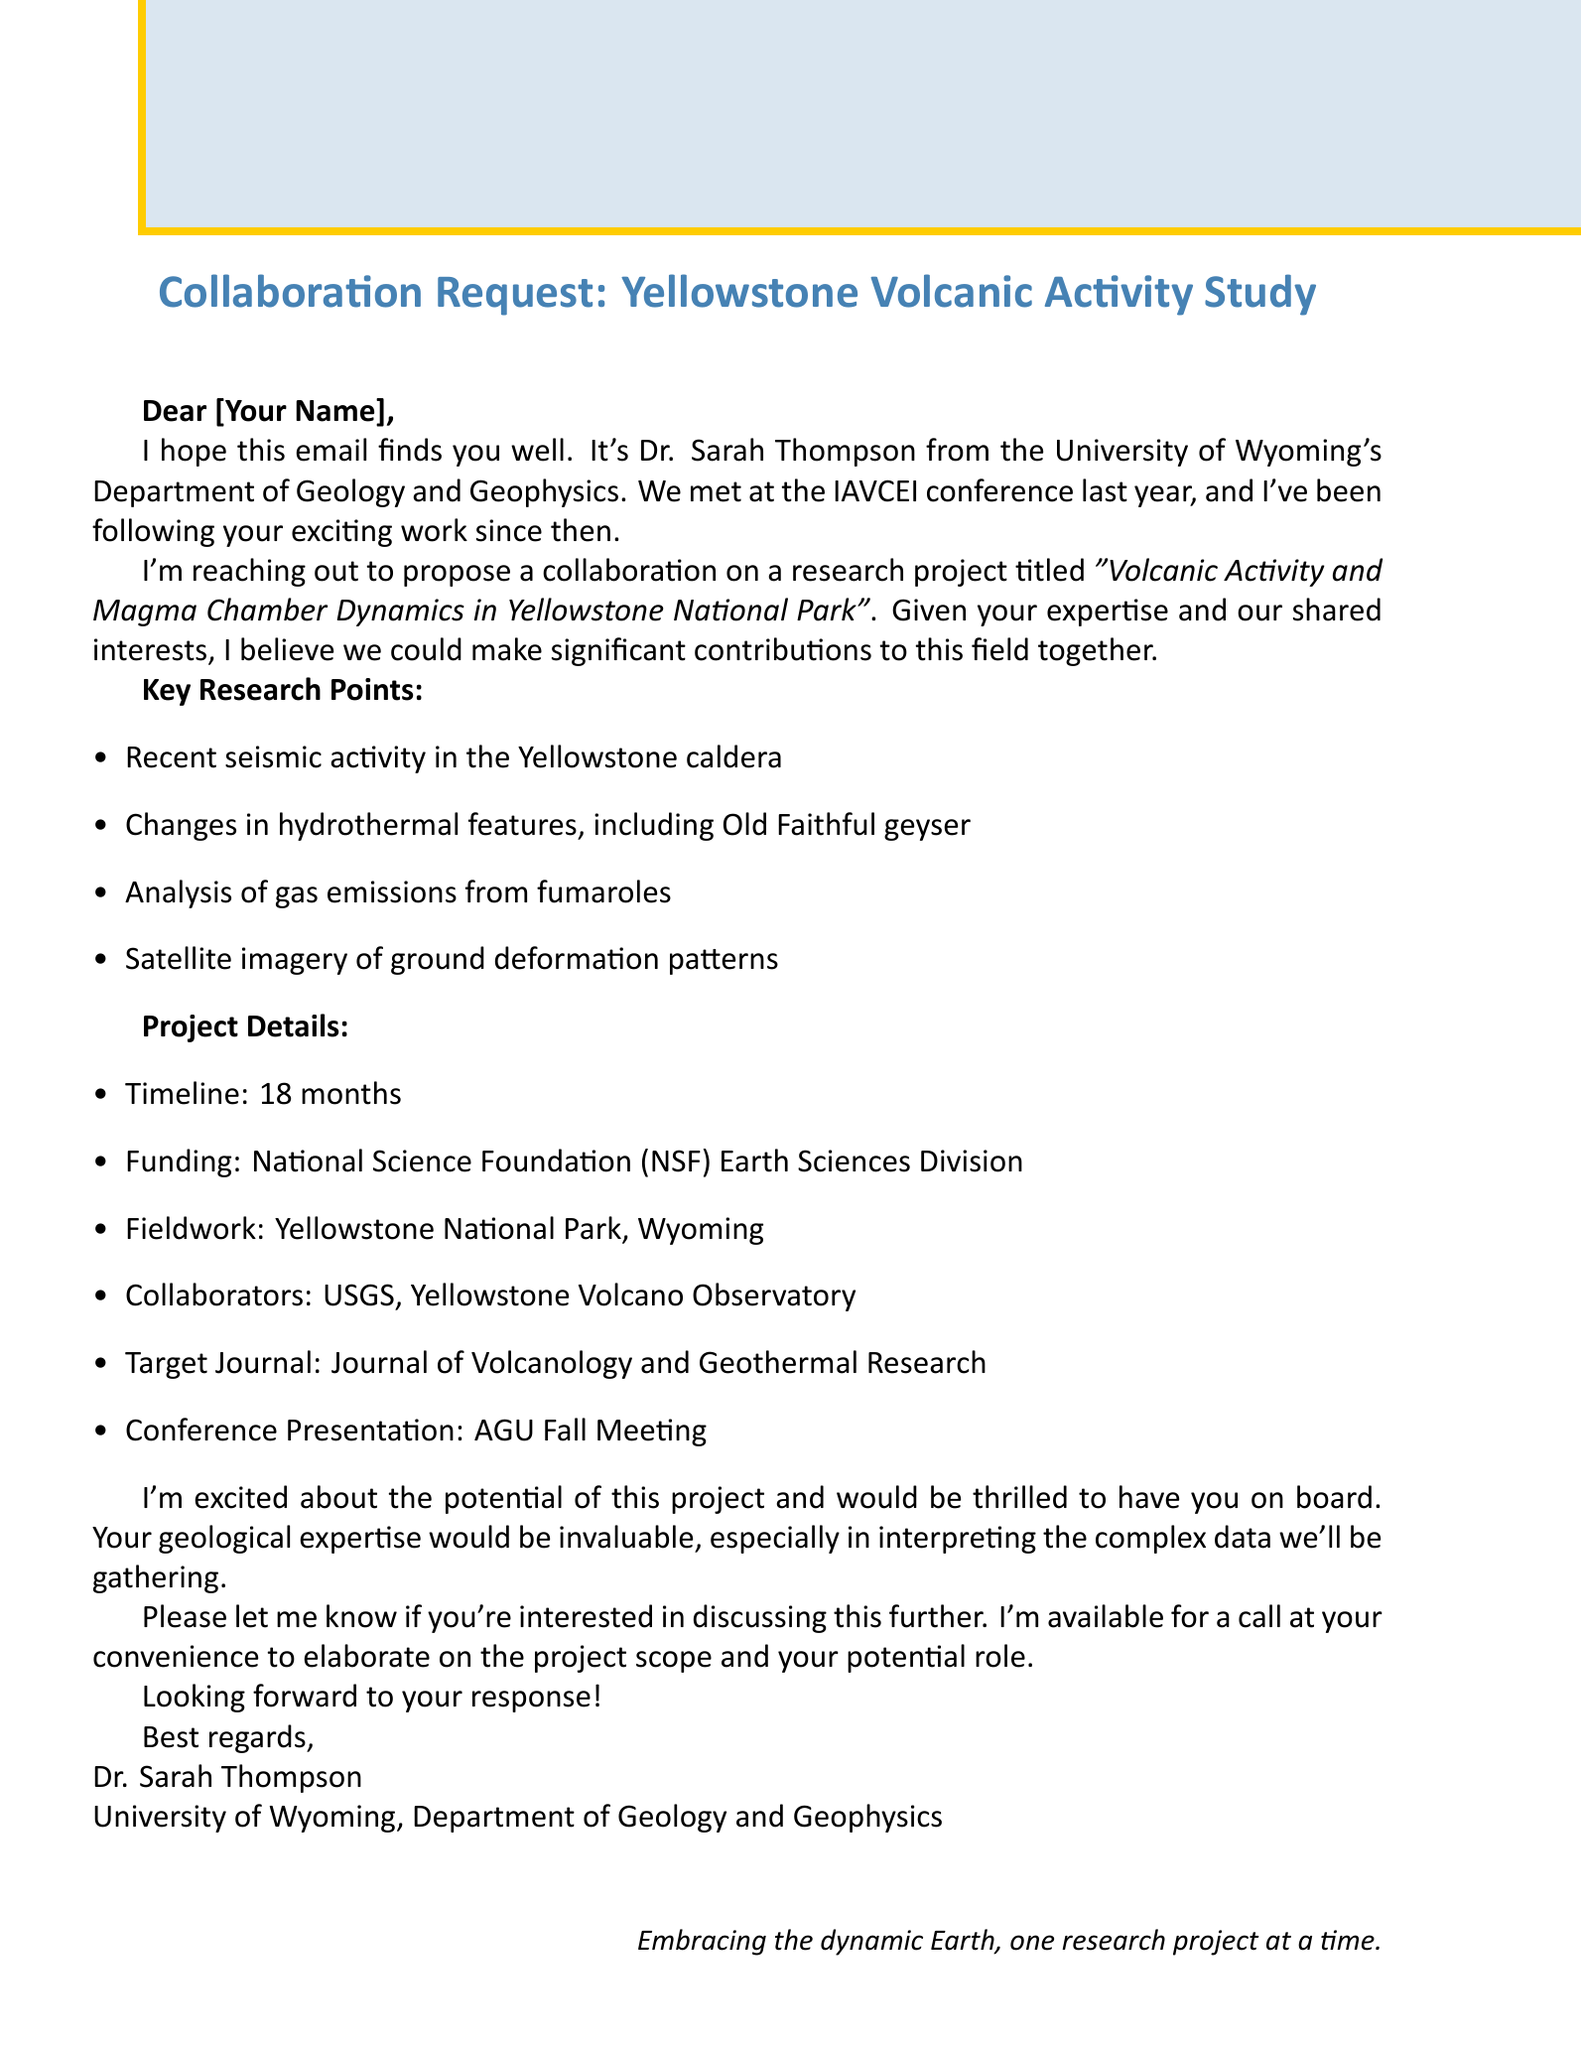What is the sender's name? The sender is Dr. Sarah Thompson, as indicated in the document.
Answer: Dr. Sarah Thompson What is the recipient's name? The recipient is addressed as "Your Name" in the email.
Answer: Your Name What is the project title? The project title is specified as "Volcanic Activity and Magma Chamber Dynamics in Yellowstone National Park."
Answer: Volcanic Activity and Magma Chamber Dynamics in Yellowstone National Park What is the proposed timeline for the project? The document states that the project timeline is 18 months.
Answer: 18 months Which funding source is mentioned? The funding source highlighted in the email is the National Science Foundation (NSF) Earth Sciences Division.
Answer: National Science Foundation (NSF) Earth Sciences Division What institution is affiliated with Dr. Sarah Thompson? Dr. Sarah Thompson is affiliated with the University of Wyoming's Department of Geology and Geophysics.
Answer: University of Wyoming, Department of Geology and Geophysics What is a key research point related to hydrothermal features? The document mentions "Changes in hydrothermal features, including Old Faithful geyser" as a key research point.
Answer: Changes in hydrothermal features, including Old Faithful geyser Which journal is targeted for publication? The targeted journal for the research publication is the Journal of Volcanology and Geothermal Research.
Answer: Journal of Volcanology and Geothermal Research What conference is the research intended to be presented at? The email mentions that the research will be presented at the AGU Fall Meeting.
Answer: AGU Fall Meeting 